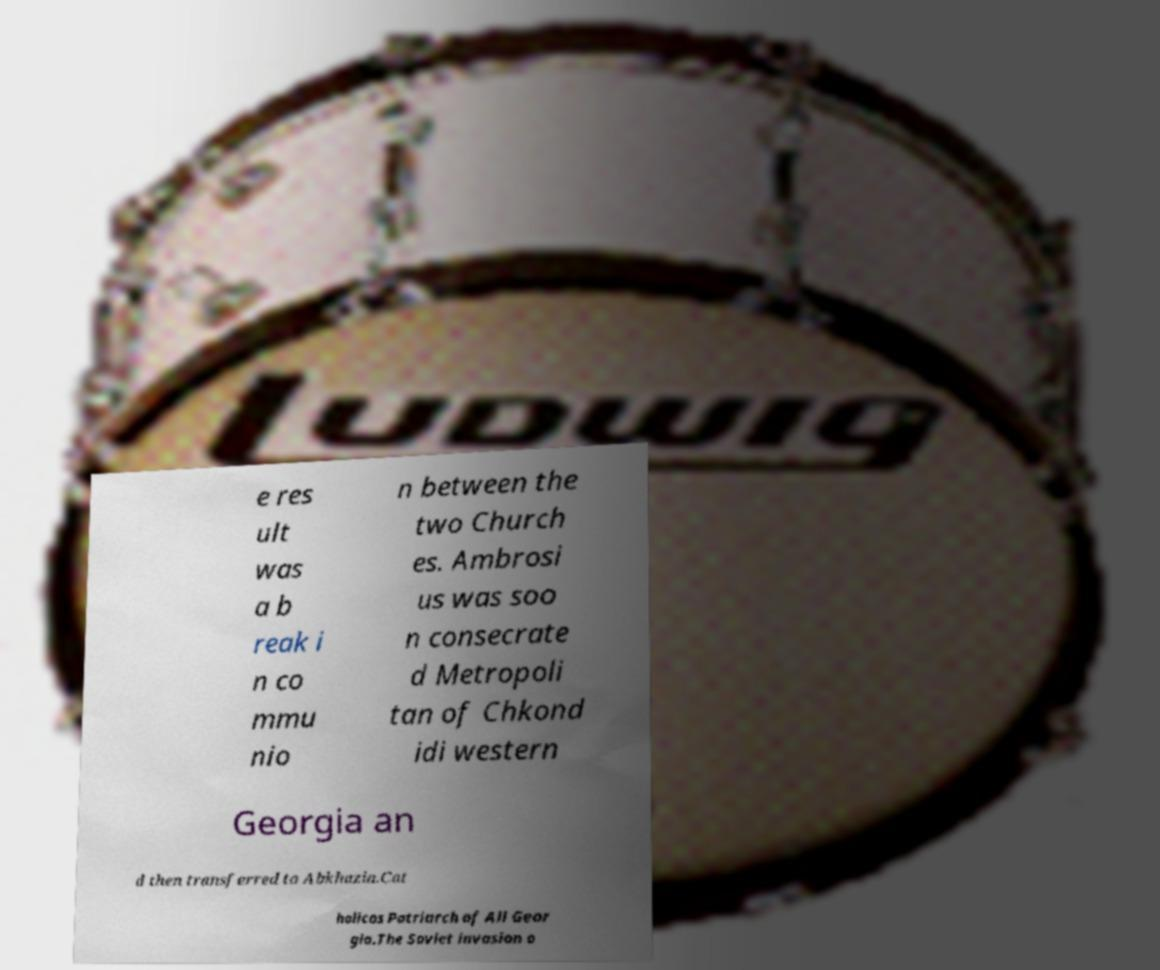Can you accurately transcribe the text from the provided image for me? e res ult was a b reak i n co mmu nio n between the two Church es. Ambrosi us was soo n consecrate d Metropoli tan of Chkond idi western Georgia an d then transferred to Abkhazia.Cat holicos Patriarch of All Geor gia.The Soviet invasion o 